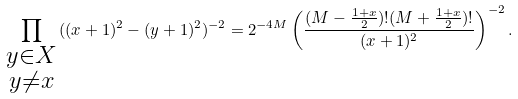Convert formula to latex. <formula><loc_0><loc_0><loc_500><loc_500>\prod _ { \begin{smallmatrix} y \in X \\ y \neq x \end{smallmatrix} } ( ( x + 1 ) ^ { 2 } - ( y + 1 ) ^ { 2 } ) ^ { - 2 } = 2 ^ { - 4 M } \left ( \frac { ( M - \frac { 1 + x } { 2 } ) ! ( M + \frac { 1 + x } { 2 } ) ! } { ( x + 1 ) ^ { 2 } } \right ) ^ { - 2 } .</formula> 